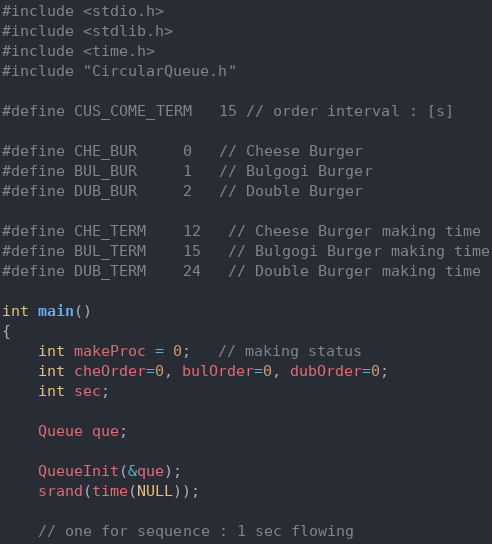<code> <loc_0><loc_0><loc_500><loc_500><_C_>#include <stdio.h>
#include <stdlib.h>
#include <time.h>
#include "CircularQueue.h"

#define CUS_COME_TERM   15 // order interval : [s]

#define CHE_BUR     0   // Cheese Burger
#define BUL_BUR     1   // Bulgogi Burger
#define DUB_BUR     2   // Double Burger

#define CHE_TERM    12   // Cheese Burger making time
#define BUL_TERM    15   // Bulgogi Burger making time
#define DUB_TERM    24   // Double Burger making time

int main()
{
    int makeProc = 0;   // making status
    int cheOrder=0, bulOrder=0, dubOrder=0;
    int sec;

    Queue que;

    QueueInit(&que);
    srand(time(NULL));

    // one for sequence : 1 sec flowing</code> 